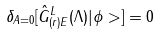Convert formula to latex. <formula><loc_0><loc_0><loc_500><loc_500>\delta _ { A = 0 } [ { \hat { G } } ^ { L } _ { ( r ) E } ( \Lambda ) | \phi > ] = 0</formula> 